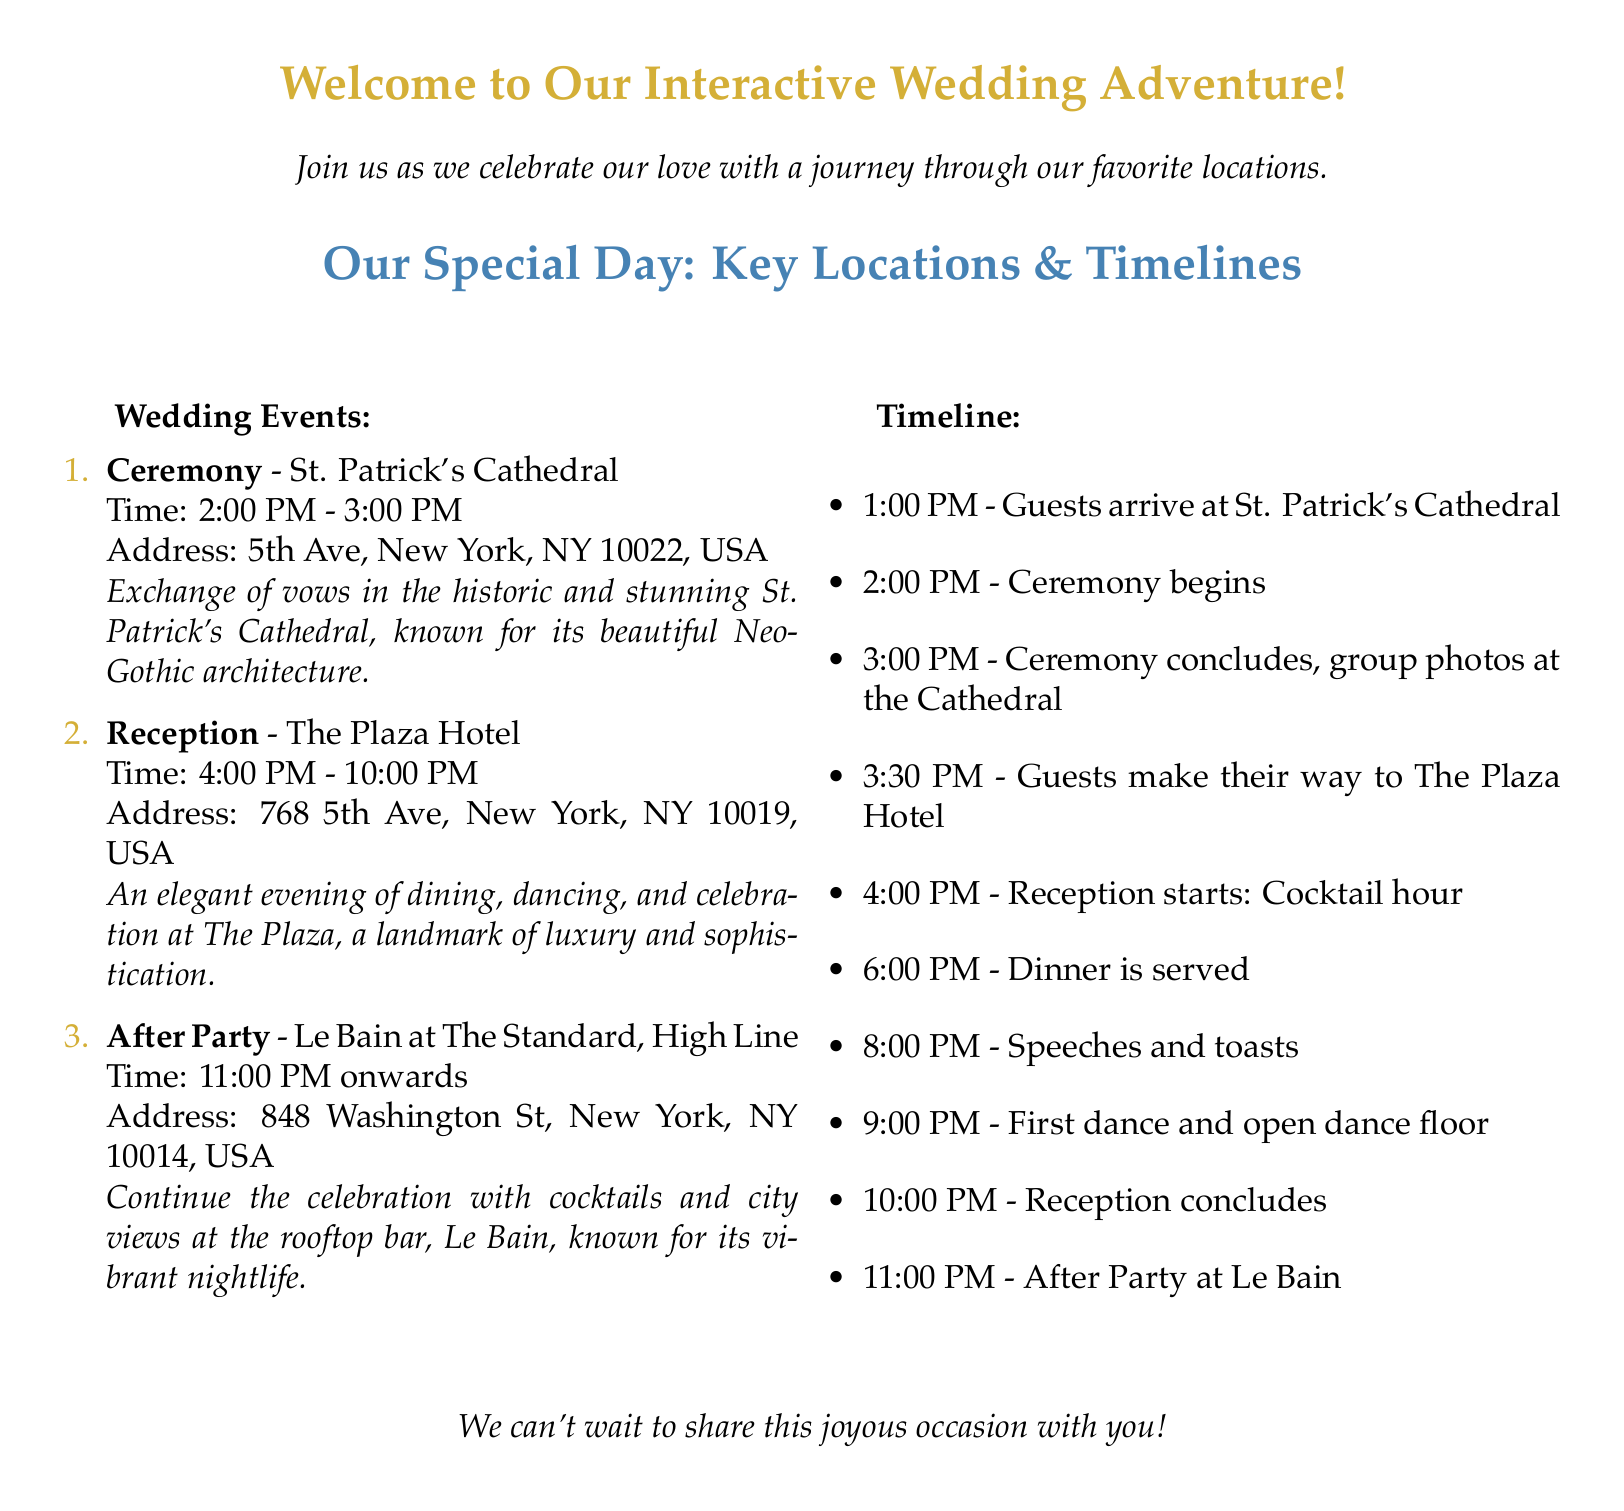What time does the ceremony begin? The ceremony is scheduled to start at 2:00 PM.
Answer: 2:00 PM What is the address of the reception venue? The address of The Plaza Hotel, the reception venue, is 768 5th Ave, New York, NY 10019, USA.
Answer: 768 5th Ave, New York, NY 10019, USA How long does the reception last? The reception starts at 4:00 PM and concludes at 10:00 PM, lasting a total of 6 hours.
Answer: 6 hours What is the last event listed on the timeline? The last event on the timeline is the After Party at Le Bain, starting at 11:00 PM.
Answer: After Party at Le Bain How many events are listed in the wedding invitation? There are three key wedding events mentioned: Ceremony, Reception, and After Party.
Answer: Three At what time will the guests start arriving at the ceremony? Guests are expected to arrive at the ceremony at 1:00 PM.
Answer: 1:00 PM What type of architecture is St. Patrick's Cathedral known for? The invitation describes St. Patrick's Cathedral as having beautiful Neo-Gothic architecture.
Answer: Neo-Gothic What is the main color used for the titles in the document? The main color used for the titles is mygold, which is specified for text color.
Answer: mygold What is the theme of the invitation? The theme of the invitation is an interactive wedding adventure featuring key locations.
Answer: Interactive wedding adventure 